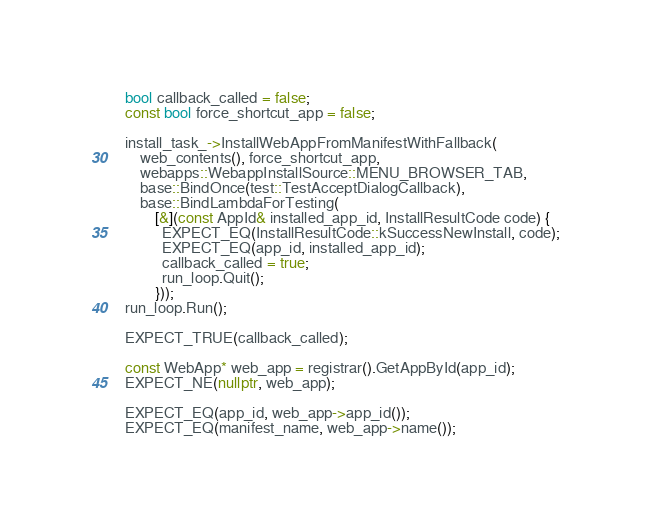Convert code to text. <code><loc_0><loc_0><loc_500><loc_500><_C++_>  bool callback_called = false;
  const bool force_shortcut_app = false;

  install_task_->InstallWebAppFromManifestWithFallback(
      web_contents(), force_shortcut_app,
      webapps::WebappInstallSource::MENU_BROWSER_TAB,
      base::BindOnce(test::TestAcceptDialogCallback),
      base::BindLambdaForTesting(
          [&](const AppId& installed_app_id, InstallResultCode code) {
            EXPECT_EQ(InstallResultCode::kSuccessNewInstall, code);
            EXPECT_EQ(app_id, installed_app_id);
            callback_called = true;
            run_loop.Quit();
          }));
  run_loop.Run();

  EXPECT_TRUE(callback_called);

  const WebApp* web_app = registrar().GetAppById(app_id);
  EXPECT_NE(nullptr, web_app);

  EXPECT_EQ(app_id, web_app->app_id());
  EXPECT_EQ(manifest_name, web_app->name());</code> 